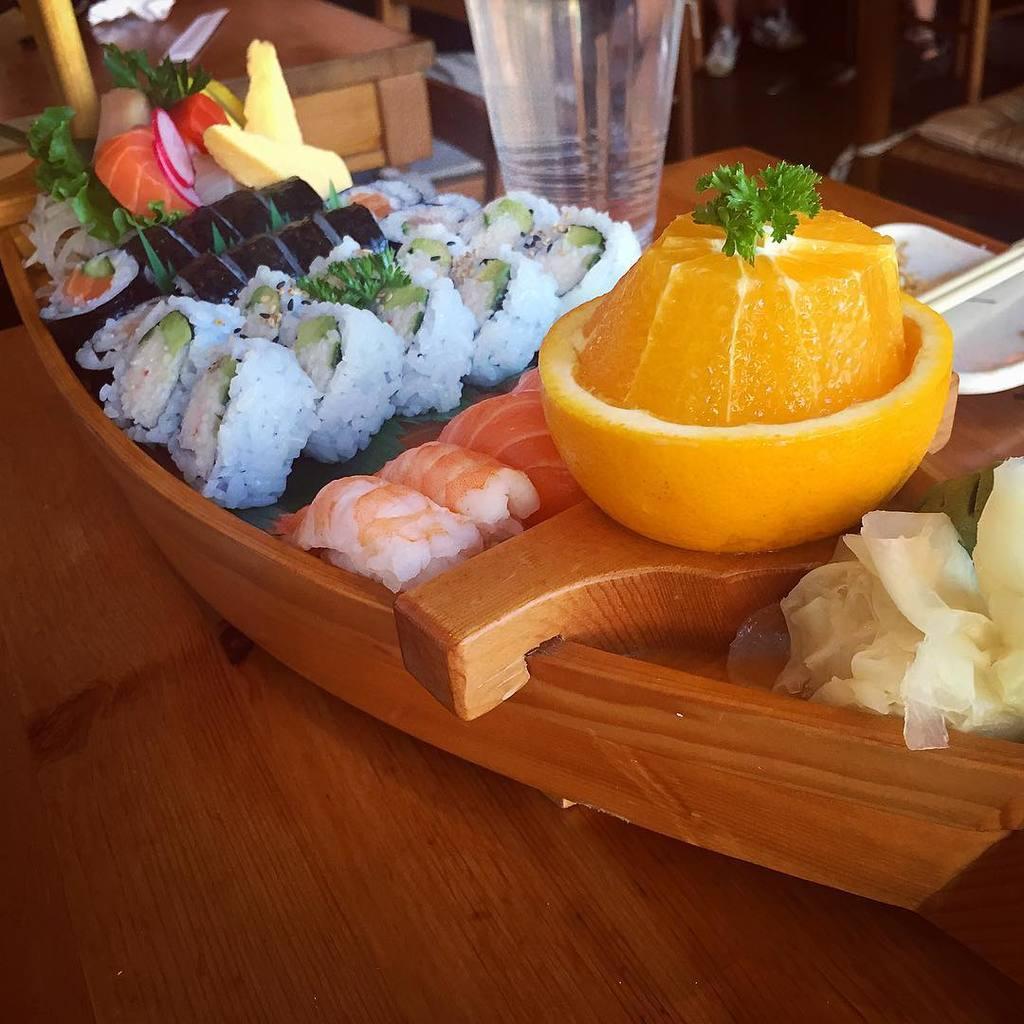Please provide a concise description of this image. This picture is of inside. In the foreground there is a table on the top of which a platter containing sushi and some food items are placed and there is a plate and a glass is also placed on the top of the table. In the background we can see a chair and another table. 